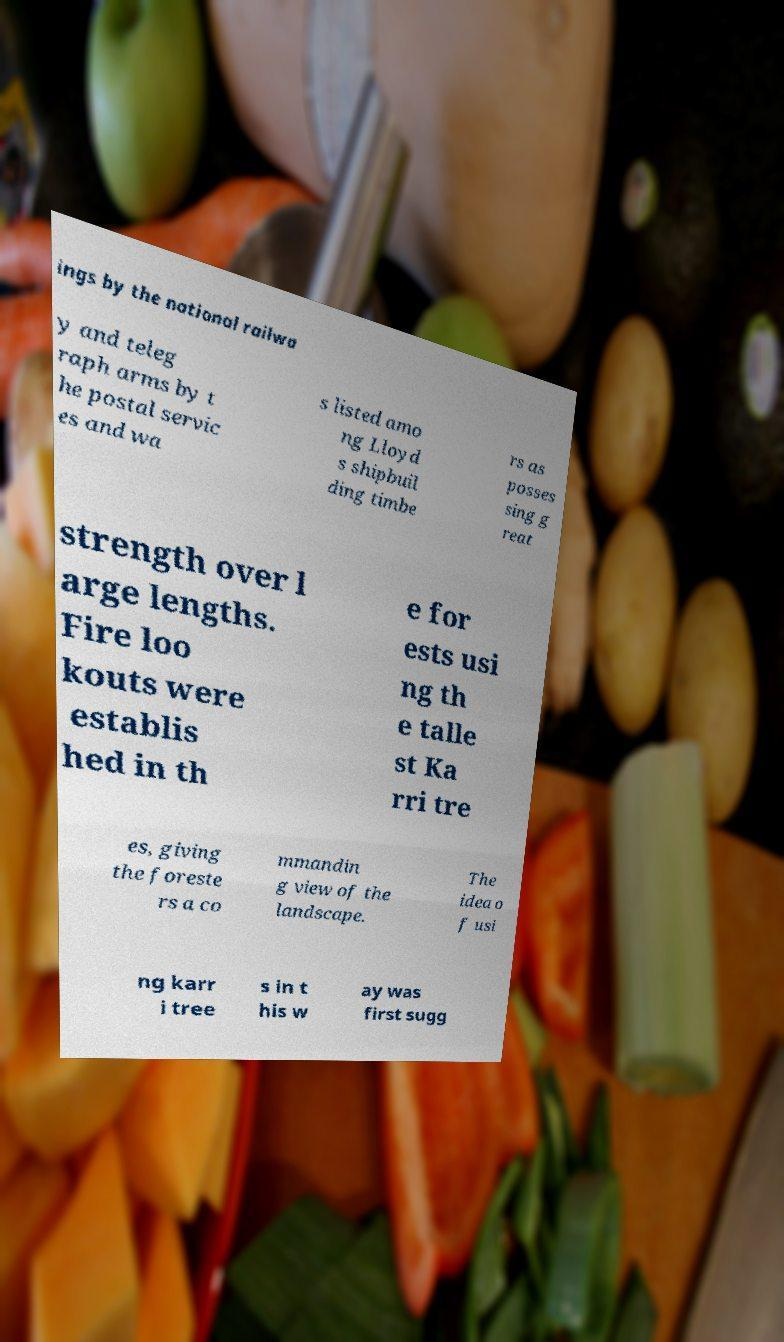Can you read and provide the text displayed in the image?This photo seems to have some interesting text. Can you extract and type it out for me? ings by the national railwa y and teleg raph arms by t he postal servic es and wa s listed amo ng Lloyd s shipbuil ding timbe rs as posses sing g reat strength over l arge lengths. Fire loo kouts were establis hed in th e for ests usi ng th e talle st Ka rri tre es, giving the foreste rs a co mmandin g view of the landscape. The idea o f usi ng karr i tree s in t his w ay was first sugg 